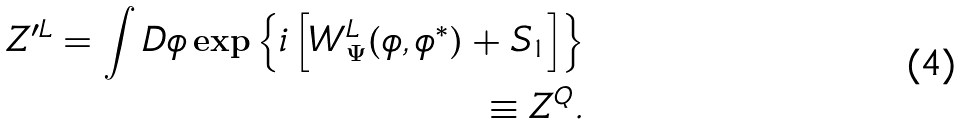<formula> <loc_0><loc_0><loc_500><loc_500>Z ^ { \prime L } = \int D \phi \exp \left \{ i \left [ W ^ { L } _ { \Psi } ( \phi , \phi ^ { * } ) + S _ { 1 } \right ] \right \} \\ \equiv Z ^ { Q } .</formula> 